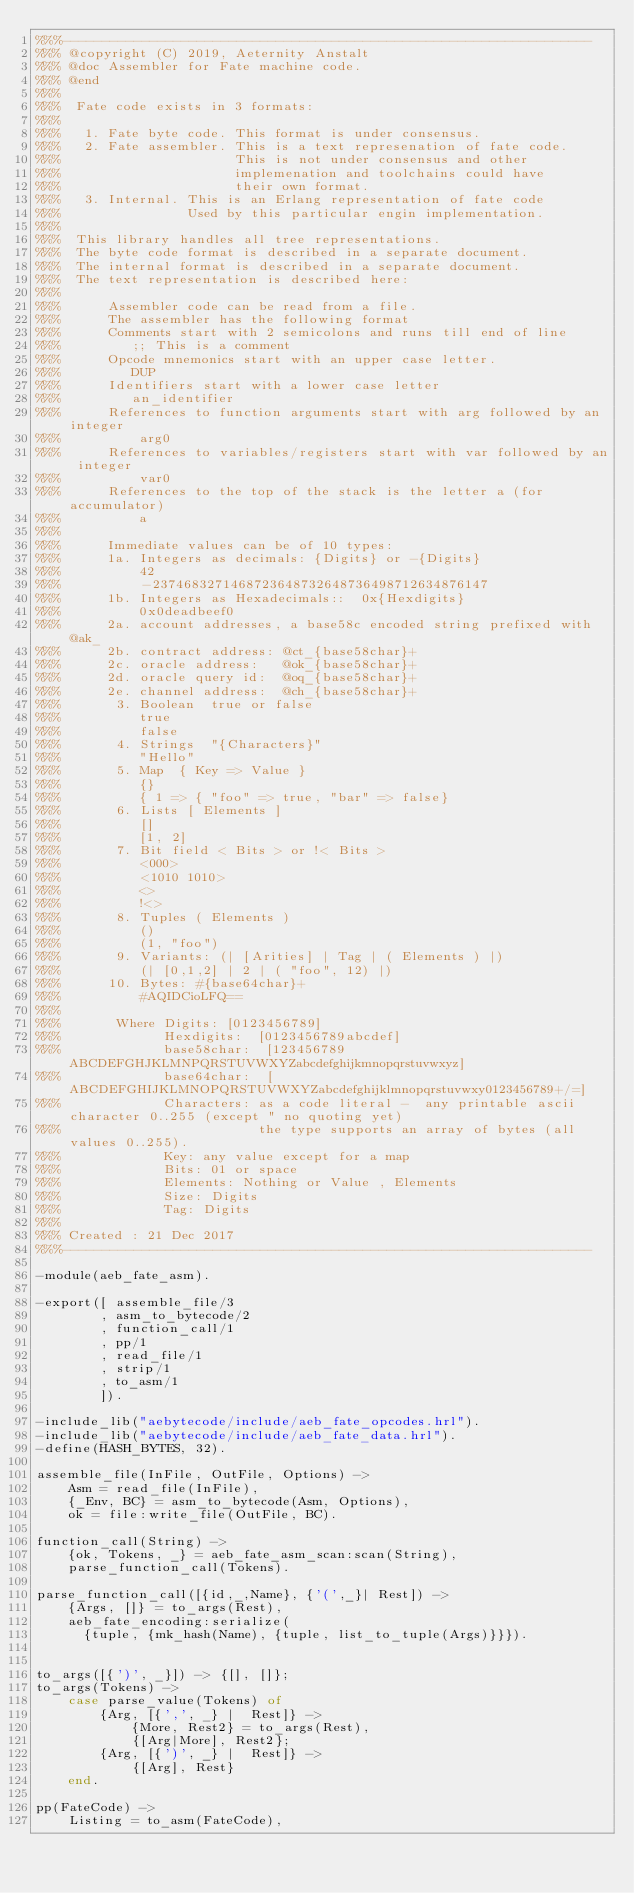<code> <loc_0><loc_0><loc_500><loc_500><_Erlang_>%%%-------------------------------------------------------------------
%%% @copyright (C) 2019, Aeternity Anstalt
%%% @doc Assembler for Fate machine code.
%%% @end
%%%
%%%  Fate code exists in 3 formats:
%%%
%%%   1. Fate byte code. This format is under consensus.
%%%   2. Fate assembler. This is a text represenation of fate code.
%%%                      This is not under consensus and other
%%%                      implemenation and toolchains could have
%%%                      their own format.
%%%   3. Internal. This is an Erlang representation of fate code
%%%                Used by this particular engin implementation.
%%%
%%%  This library handles all tree representations.
%%%  The byte code format is described in a separate document.
%%%  The internal format is described in a separate document.
%%%  The text representation is described here:
%%%
%%%      Assembler code can be read from a file.
%%%      The assembler has the following format
%%%      Comments start with 2 semicolons and runs till end of line
%%%         ;; This is a comment
%%%      Opcode mnemonics start with an upper case letter.
%%%         DUP
%%%      Identifiers start with a lower case letter
%%%         an_identifier
%%%      References to function arguments start with arg followed by an integer
%%%          arg0
%%%      References to variables/registers start with var followed by an integer
%%%          var0
%%%      References to the top of the stack is the letter a (for accumulator)
%%%          a
%%%
%%%      Immediate values can be of 10 types:
%%%      1a. Integers as decimals: {Digits} or -{Digits}
%%%          42
%%%          -2374683271468723648732648736498712634876147
%%%      1b. Integers as Hexadecimals::  0x{Hexdigits}
%%%          0x0deadbeef0
%%%      2a. account addresses, a base58c encoded string prefixed with @ak_
%%%      2b. contract address: @ct_{base58char}+
%%%      2c. oracle address:   @ok_{base58char}+
%%%      2d. oracle query id:  @oq_{base58char}+
%%%      2e. channel address:  @ch_{base58char}+
%%%       3. Boolean  true or false
%%%          true
%%%          false
%%%       4. Strings  "{Characters}"
%%%          "Hello"
%%%       5. Map  { Key => Value }
%%%          {}
%%%          { 1 => { "foo" => true, "bar" => false}
%%%       6. Lists [ Elements ]
%%%          []
%%%          [1, 2]
%%%       7. Bit field < Bits > or !< Bits >
%%%          <000>
%%%          <1010 1010>
%%%          <>
%%%          !<>
%%%       8. Tuples ( Elements )
%%%          ()
%%%          (1, "foo")
%%%       9. Variants: (| [Arities] | Tag | ( Elements ) |)
%%%          (| [0,1,2] | 2 | ( "foo", 12) |)
%%%      10. Bytes: #{base64char}+
%%%          #AQIDCioLFQ==
%%%
%%%       Where Digits: [0123456789]
%%%             Hexdigits:  [0123456789abcdef]
%%%             base58char:  [123456789ABCDEFGHJKLMNPQRSTUVWXYZabcdefghijkmnopqrstuvwxyz]
%%%             base64char:  [ABCDEFGHIJKLMNOPQRSTUVWXYZabcdefghijklmnopqrstuvwxy0123456789+/=]
%%%             Characters: as a code literal -  any printable ascii character 0..255 (except " no quoting yet)
%%%                         the type supports an array of bytes (all values 0..255).
%%%             Key: any value except for a map
%%%             Bits: 01 or space
%%%             Elements: Nothing or Value , Elements
%%%             Size: Digits
%%%             Tag: Digits
%%%
%%% Created : 21 Dec 2017
%%%-------------------------------------------------------------------

-module(aeb_fate_asm).

-export([ assemble_file/3
        , asm_to_bytecode/2
        , function_call/1
        , pp/1
        , read_file/1
        , strip/1
        , to_asm/1
        ]).

-include_lib("aebytecode/include/aeb_fate_opcodes.hrl").
-include_lib("aebytecode/include/aeb_fate_data.hrl").
-define(HASH_BYTES, 32).

assemble_file(InFile, OutFile, Options) ->
    Asm = read_file(InFile),
    {_Env, BC} = asm_to_bytecode(Asm, Options),
    ok = file:write_file(OutFile, BC).

function_call(String) ->
    {ok, Tokens, _} = aeb_fate_asm_scan:scan(String),
    parse_function_call(Tokens).

parse_function_call([{id,_,Name}, {'(',_}| Rest]) ->
    {Args, []} = to_args(Rest),
    aeb_fate_encoding:serialize(
      {tuple, {mk_hash(Name), {tuple, list_to_tuple(Args)}}}).


to_args([{')', _}]) -> {[], []};
to_args(Tokens) ->
    case parse_value(Tokens) of
        {Arg, [{',', _} |  Rest]} ->
            {More, Rest2} = to_args(Rest),
            {[Arg|More], Rest2};
        {Arg, [{')', _} |  Rest]} ->
            {[Arg], Rest}
    end.

pp(FateCode) ->
    Listing = to_asm(FateCode),</code> 